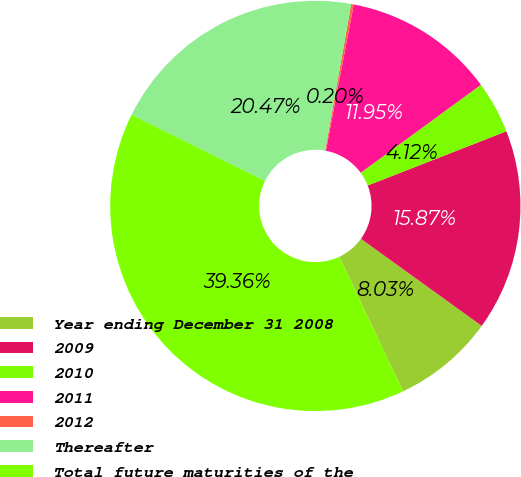<chart> <loc_0><loc_0><loc_500><loc_500><pie_chart><fcel>Year ending December 31 2008<fcel>2009<fcel>2010<fcel>2011<fcel>2012<fcel>Thereafter<fcel>Total future maturities of the<nl><fcel>8.03%<fcel>15.87%<fcel>4.12%<fcel>11.95%<fcel>0.2%<fcel>20.47%<fcel>39.36%<nl></chart> 